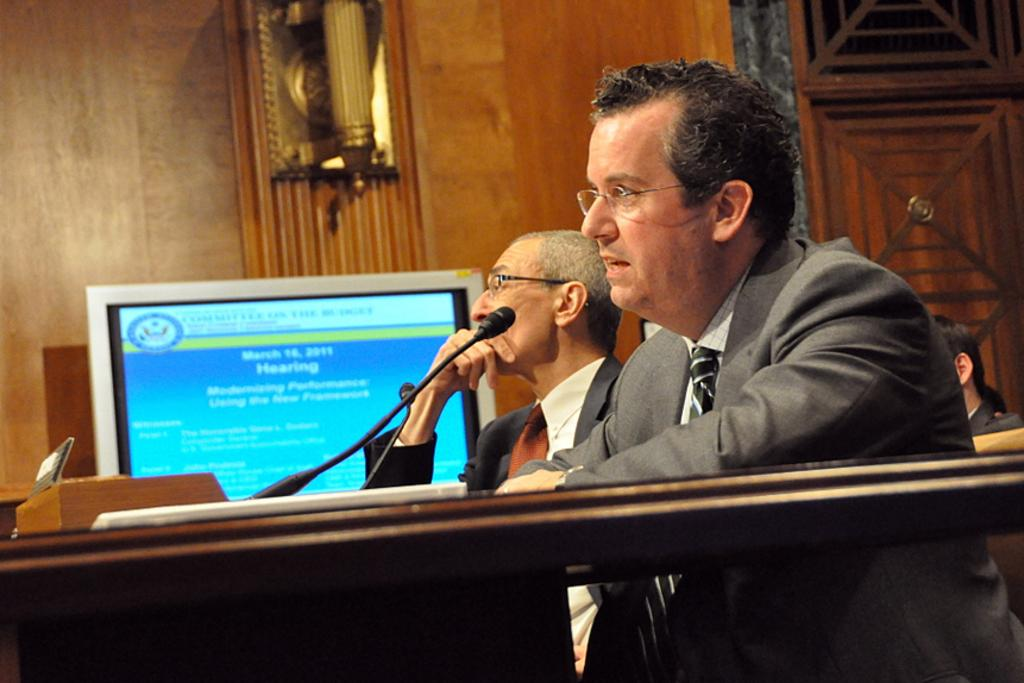How many people are in the image? There are two persons in front of the desk and another person in the background, making a total of three people in the image. What object is on the desk? There is a microphone on the desk. What can be seen in the background of the image? There is a wall and a huge screen in the background. What type of muscle is being exercised by the person in the image? There is no indication of any person exercising in the image, so it cannot be determined which muscle is being exercised. 